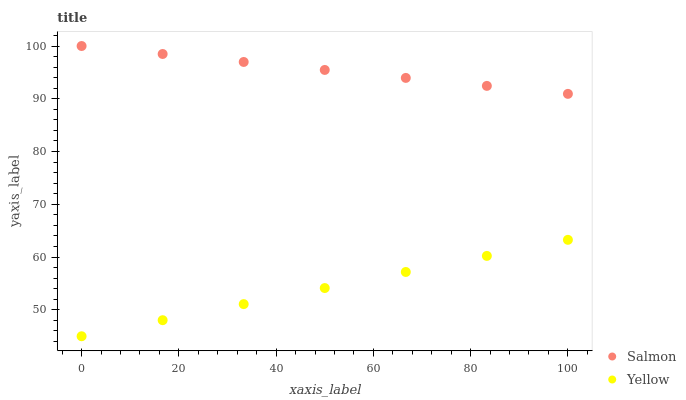Does Yellow have the minimum area under the curve?
Answer yes or no. Yes. Does Salmon have the maximum area under the curve?
Answer yes or no. Yes. Does Yellow have the maximum area under the curve?
Answer yes or no. No. Is Yellow the smoothest?
Answer yes or no. Yes. Is Salmon the roughest?
Answer yes or no. Yes. Is Yellow the roughest?
Answer yes or no. No. Does Yellow have the lowest value?
Answer yes or no. Yes. Does Salmon have the highest value?
Answer yes or no. Yes. Does Yellow have the highest value?
Answer yes or no. No. Is Yellow less than Salmon?
Answer yes or no. Yes. Is Salmon greater than Yellow?
Answer yes or no. Yes. Does Yellow intersect Salmon?
Answer yes or no. No. 